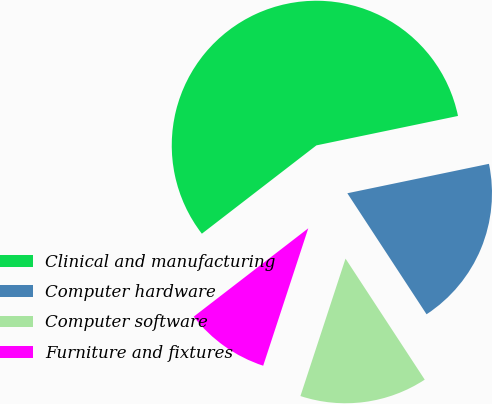Convert chart. <chart><loc_0><loc_0><loc_500><loc_500><pie_chart><fcel>Clinical and manufacturing<fcel>Computer hardware<fcel>Computer software<fcel>Furniture and fixtures<nl><fcel>57.2%<fcel>19.04%<fcel>14.27%<fcel>9.5%<nl></chart> 